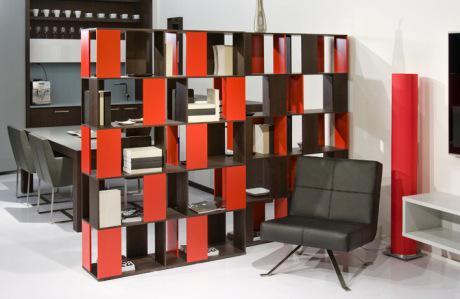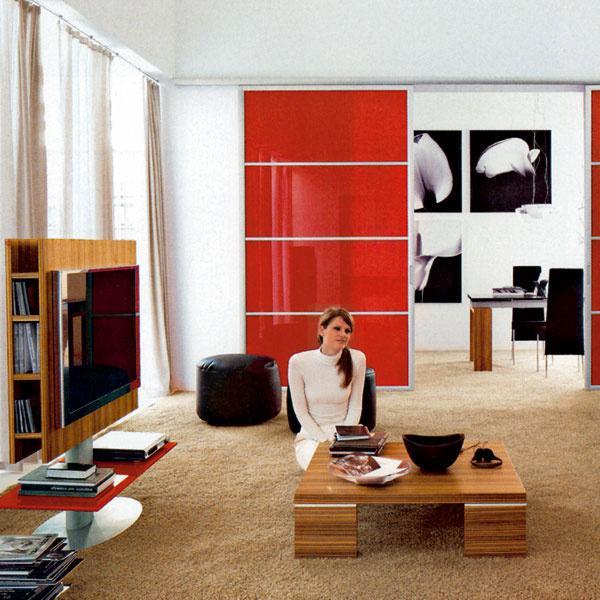The first image is the image on the left, the second image is the image on the right. Considering the images on both sides, is "Left image shows a free-standing shelf divider featuring orange color." valid? Answer yes or no. Yes. The first image is the image on the left, the second image is the image on the right. Evaluate the accuracy of this statement regarding the images: "In one image, tall, colorful open shelves, that are partly orange, are used as a room divider.". Is it true? Answer yes or no. Yes. 